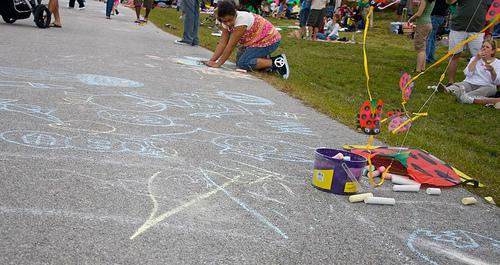Question: who likely drew this art?
Choices:
A. A painter.
B. Children.
C. A student.
D. An artist.
Answer with the letter. Answer: B Question: what color is the chalk bucket?
Choices:
A. Black.
B. Brown.
C. White.
D. Purple.
Answer with the letter. Answer: D Question: where are the drawings?
Choices:
A. In sketch book.
B. In the classroom.
C. Sidewalk.
D. On the desk.
Answer with the letter. Answer: C Question: what symbol is on the girl's shoes?
Choices:
A. A corporate logo.
B. A circle.
C. Peace sign.
D. A heart.
Answer with the letter. Answer: C Question: what type of bug is represented on the right?
Choices:
A. Centipede.
B. Ant.
C. Ladybug.
D. Roach.
Answer with the letter. Answer: C Question: how many buckets are there?
Choices:
A. 1.
B. None.
C. Two.
D. Four.
Answer with the letter. Answer: A 